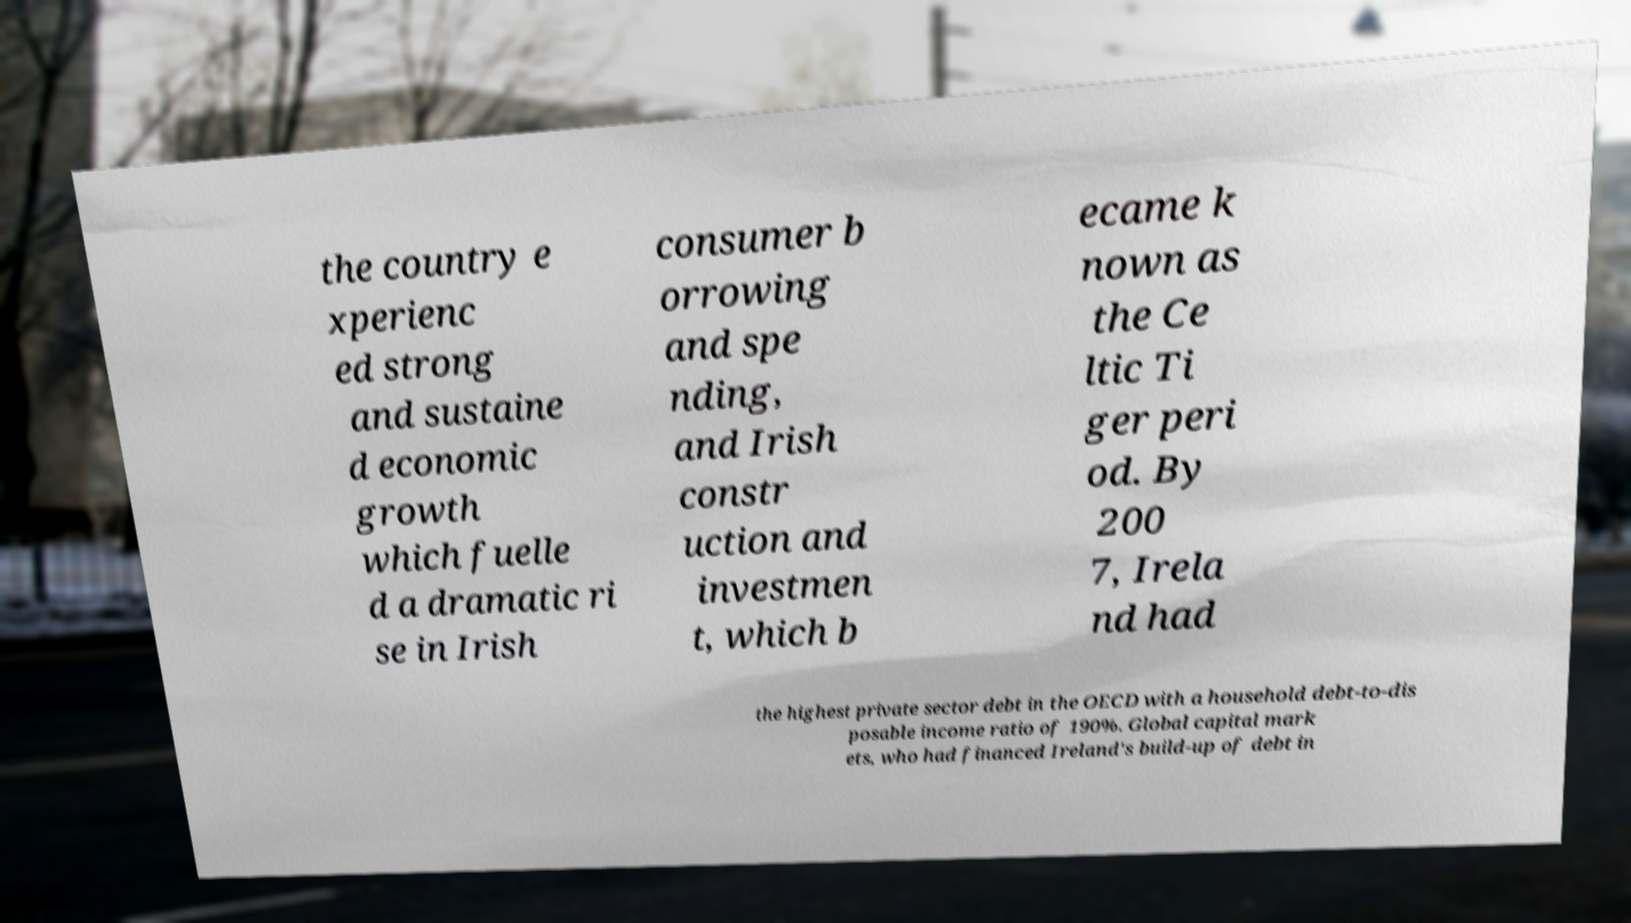Please read and relay the text visible in this image. What does it say? the country e xperienc ed strong and sustaine d economic growth which fuelle d a dramatic ri se in Irish consumer b orrowing and spe nding, and Irish constr uction and investmen t, which b ecame k nown as the Ce ltic Ti ger peri od. By 200 7, Irela nd had the highest private sector debt in the OECD with a household debt-to-dis posable income ratio of 190%. Global capital mark ets, who had financed Ireland's build-up of debt in 